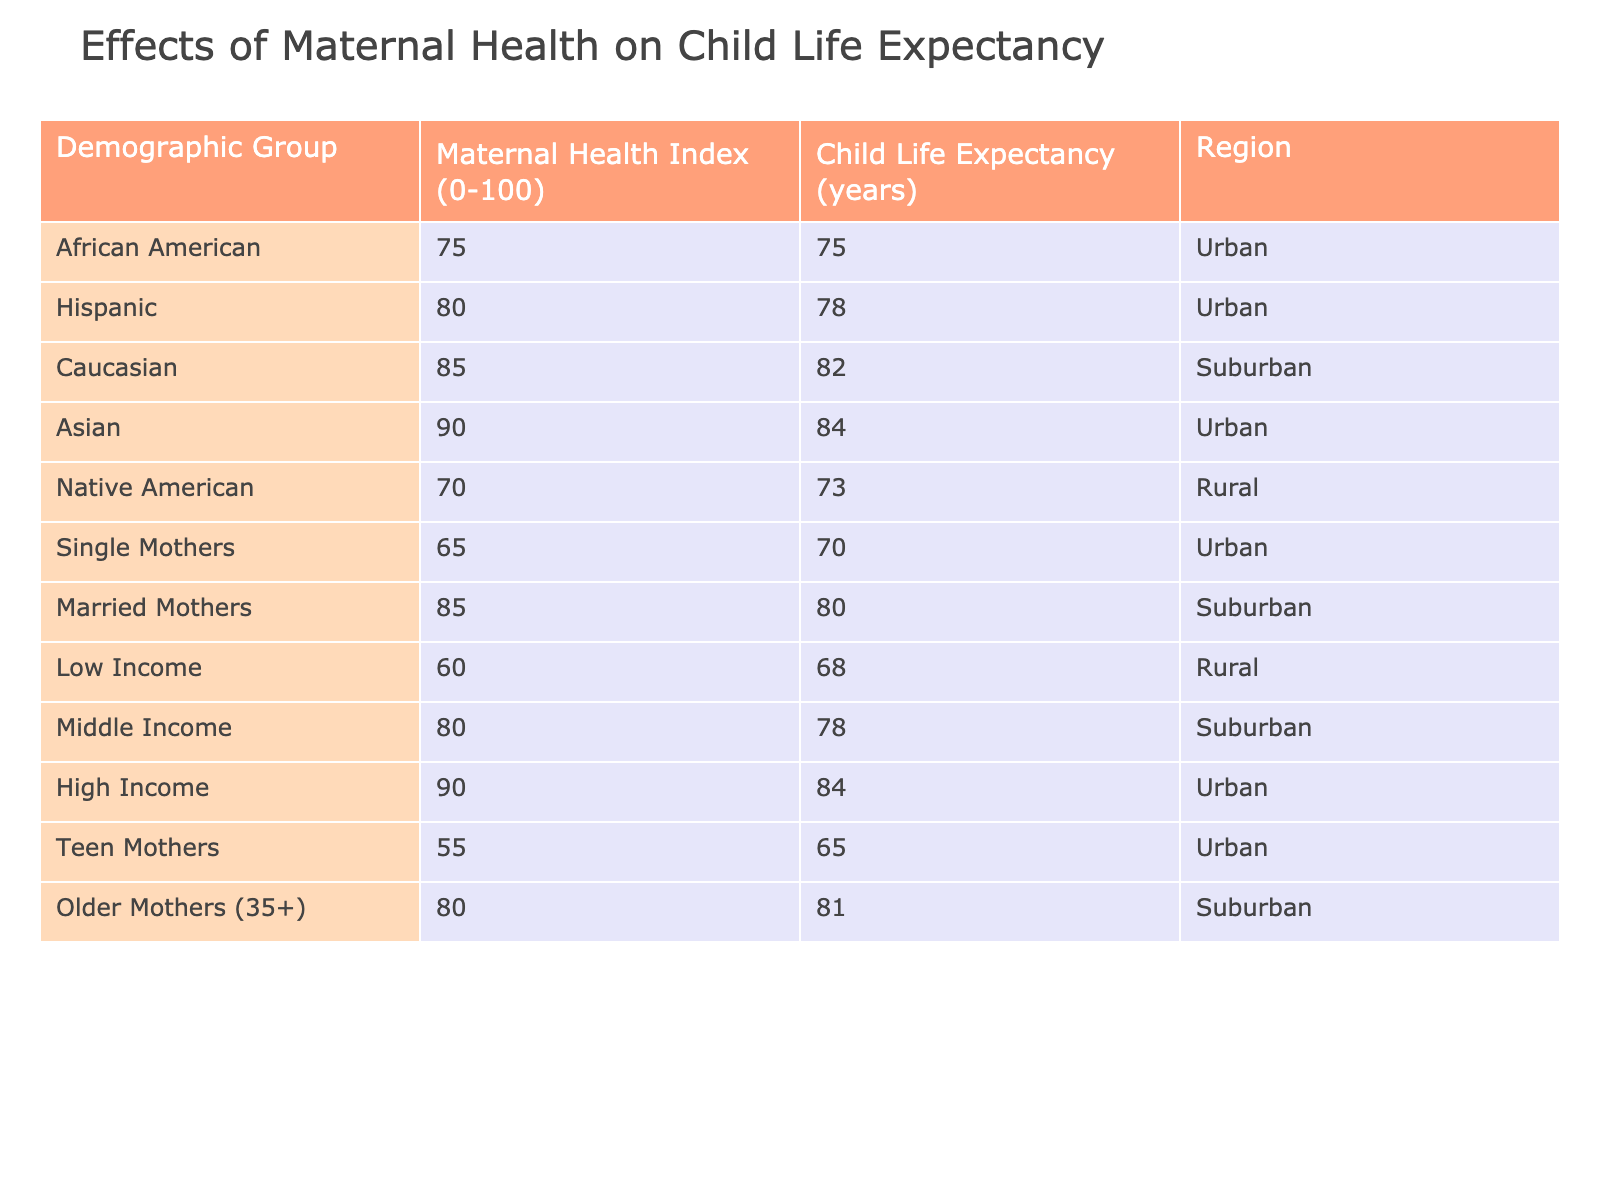What is the Child Life Expectancy for Teen Mothers? The table indicates that the Child Life Expectancy for Teen Mothers is 65 years as listed under the relevant demographic group.
Answer: 65 What is the Maternal Health Index for Single Mothers? The Maternal Health Index for Single Mothers is represented in the table as 65.
Answer: 65 Which demographic group has the highest Child Life Expectancy? By comparing the Child Life Expectancy values in the table, the demographic group with the highest Child Life Expectancy is Asian with 84 years.
Answer: 84 What is the average Child Life Expectancy for Rural demographics? The Child Life Expectancy for Native American (73) and Low Income (68) is available in the table. The average is calculated as (73 + 68) / 2 = 70.5.
Answer: 70.5 Is it true that Married Mothers have a higher Child Life Expectancy than Single Mothers? From the table, Married Mothers have a Child Life Expectancy of 80 years, while Single Mothers have 70 years. Therefore, it is true that Married Mothers have a higher life expectancy.
Answer: Yes What is the difference in Child Life Expectancy between High Income and Low Income groups? The Child Life Expectancy for High Income is 84 years and for Low Income it is 68 years. The difference is calculated as 84 - 68 = 16 years.
Answer: 16 What is the Child Life Expectancy for Caucasian demographic? The table lists the Child Life Expectancy for Caucasian as 82 years.
Answer: 82 Are all Urban demographics showing a Child Life Expectancy above 70 years? Analyzing the Urban demographics in the table: African American (75), Hispanic (78), Single Mothers (70), Asian (84), and Teen Mothers (65). Since Teen Mothers have 65, the statement is false.
Answer: No What is the relationship between Maternal Health Index and Child Life Expectancy for Married Mothers and High Income groups? For Married Mothers, the Maternal Health Index is 85 with 80 years of Child Life Expectancy. In comparison, High Income has a Maternal Health Index of 90 with 84 years of Child Life Expectancy. Both groups have high indices and relatively high life expectancies, but High Income has both higher indices and life expectancies.
Answer: High Income shows higher values 